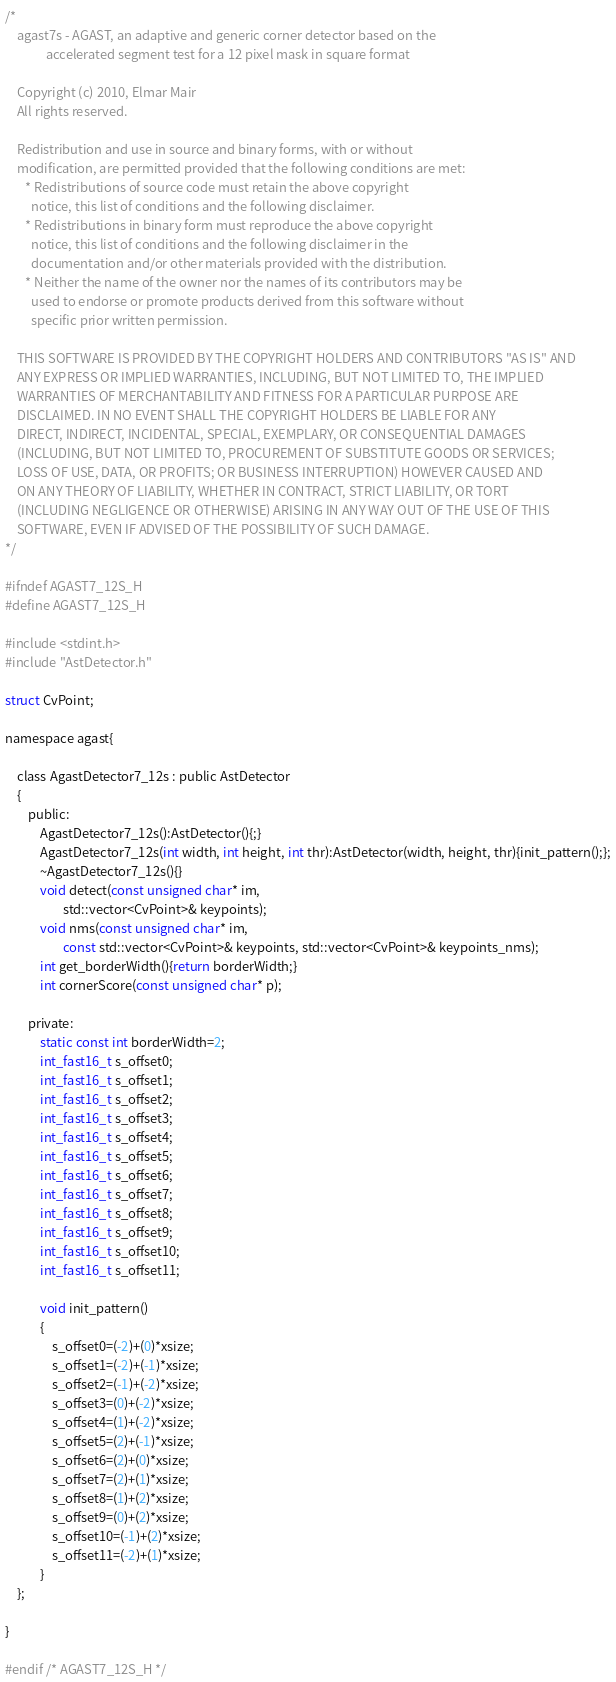Convert code to text. <code><loc_0><loc_0><loc_500><loc_500><_C_>/*
    agast7s - AGAST, an adaptive and generic corner detector based on the
              accelerated segment test for a 12 pixel mask in square format

    Copyright (c) 2010, Elmar Mair
    All rights reserved.
   
    Redistribution and use in source and binary forms, with or without
    modification, are permitted provided that the following conditions are met:
       * Redistributions of source code must retain the above copyright
         notice, this list of conditions and the following disclaimer.
       * Redistributions in binary form must reproduce the above copyright
         notice, this list of conditions and the following disclaimer in the
         documentation and/or other materials provided with the distribution.
       * Neither the name of the owner nor the names of its contributors may be 
         used to endorse or promote products derived from this software without 
         specific prior written permission.
   
    THIS SOFTWARE IS PROVIDED BY THE COPYRIGHT HOLDERS AND CONTRIBUTORS "AS IS" AND
    ANY EXPRESS OR IMPLIED WARRANTIES, INCLUDING, BUT NOT LIMITED TO, THE IMPLIED
    WARRANTIES OF MERCHANTABILITY AND FITNESS FOR A PARTICULAR PURPOSE ARE
    DISCLAIMED. IN NO EVENT SHALL THE COPYRIGHT HOLDERS BE LIABLE FOR ANY
    DIRECT, INDIRECT, INCIDENTAL, SPECIAL, EXEMPLARY, OR CONSEQUENTIAL DAMAGES
    (INCLUDING, BUT NOT LIMITED TO, PROCUREMENT OF SUBSTITUTE GOODS OR SERVICES;
    LOSS OF USE, DATA, OR PROFITS; OR BUSINESS INTERRUPTION) HOWEVER CAUSED AND
    ON ANY THEORY OF LIABILITY, WHETHER IN CONTRACT, STRICT LIABILITY, OR TORT
    (INCLUDING NEGLIGENCE OR OTHERWISE) ARISING IN ANY WAY OUT OF THE USE OF THIS
    SOFTWARE, EVEN IF ADVISED OF THE POSSIBILITY OF SUCH DAMAGE.
*/

#ifndef AGAST7_12S_H
#define AGAST7_12S_H

#include <stdint.h>
#include "AstDetector.h"

struct CvPoint;

namespace agast{

	class AgastDetector7_12s : public AstDetector
	{
		public:
			AgastDetector7_12s():AstDetector(){;}
			AgastDetector7_12s(int width, int height, int thr):AstDetector(width, height, thr){init_pattern();};
			~AgastDetector7_12s(){}
			void detect(const unsigned char* im,
					std::vector<CvPoint>& keypoints);
			void nms(const unsigned char* im,
					const std::vector<CvPoint>& keypoints, std::vector<CvPoint>& keypoints_nms);
			int get_borderWidth(){return borderWidth;}
			int cornerScore(const unsigned char* p);

		private:
			static const int borderWidth=2;
			int_fast16_t s_offset0;
			int_fast16_t s_offset1;
			int_fast16_t s_offset2;
			int_fast16_t s_offset3;
			int_fast16_t s_offset4;
			int_fast16_t s_offset5;
			int_fast16_t s_offset6;
			int_fast16_t s_offset7;
			int_fast16_t s_offset8;
			int_fast16_t s_offset9;
			int_fast16_t s_offset10;
			int_fast16_t s_offset11;

			void init_pattern()
			{
				s_offset0=(-2)+(0)*xsize;
				s_offset1=(-2)+(-1)*xsize;
				s_offset2=(-1)+(-2)*xsize;
				s_offset3=(0)+(-2)*xsize;
				s_offset4=(1)+(-2)*xsize;
				s_offset5=(2)+(-1)*xsize;
				s_offset6=(2)+(0)*xsize;
				s_offset7=(2)+(1)*xsize;
				s_offset8=(1)+(2)*xsize;
				s_offset9=(0)+(2)*xsize;
				s_offset10=(-1)+(2)*xsize;
				s_offset11=(-2)+(1)*xsize;
			}
	};

}

#endif /* AGAST7_12S_H */
</code> 